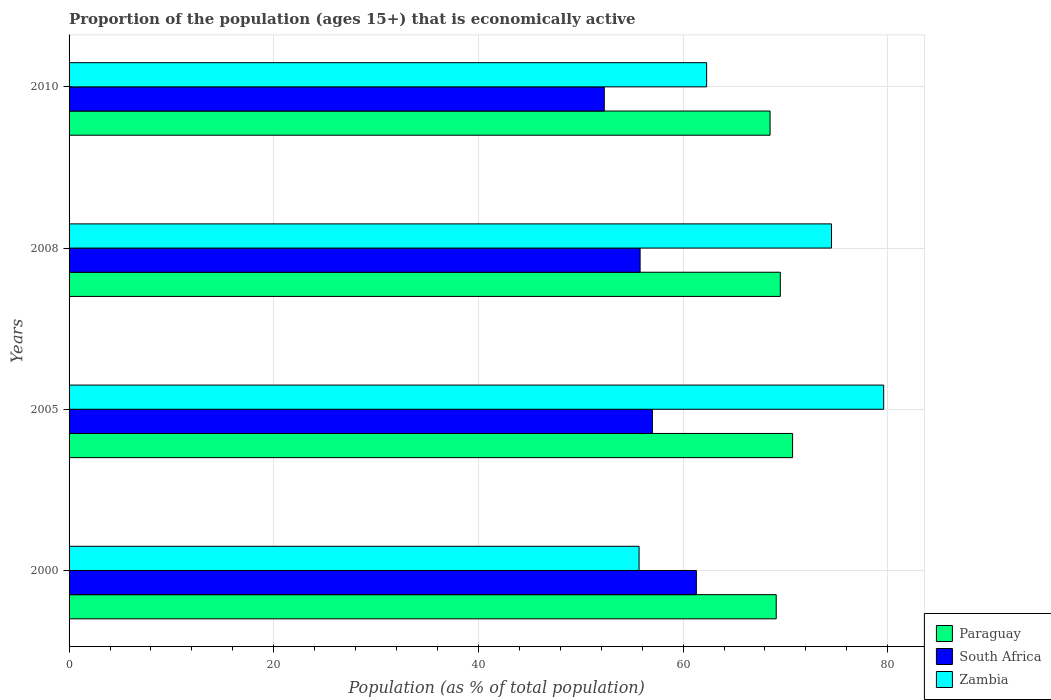How many different coloured bars are there?
Keep it short and to the point. 3. How many groups of bars are there?
Offer a very short reply. 4. Are the number of bars per tick equal to the number of legend labels?
Offer a terse response. Yes. How many bars are there on the 3rd tick from the top?
Keep it short and to the point. 3. What is the proportion of the population that is economically active in Zambia in 2005?
Give a very brief answer. 79.6. Across all years, what is the maximum proportion of the population that is economically active in Paraguay?
Provide a short and direct response. 70.7. Across all years, what is the minimum proportion of the population that is economically active in Zambia?
Offer a very short reply. 55.7. In which year was the proportion of the population that is economically active in Zambia maximum?
Make the answer very short. 2005. In which year was the proportion of the population that is economically active in South Africa minimum?
Make the answer very short. 2010. What is the total proportion of the population that is economically active in South Africa in the graph?
Provide a succinct answer. 226.4. What is the difference between the proportion of the population that is economically active in South Africa in 2005 and that in 2008?
Ensure brevity in your answer.  1.2. What is the average proportion of the population that is economically active in Zambia per year?
Ensure brevity in your answer.  68.02. What is the ratio of the proportion of the population that is economically active in Zambia in 2008 to that in 2010?
Your answer should be very brief. 1.2. Is the difference between the proportion of the population that is economically active in Paraguay in 2005 and 2008 greater than the difference between the proportion of the population that is economically active in Zambia in 2005 and 2008?
Your response must be concise. No. What is the difference between the highest and the second highest proportion of the population that is economically active in South Africa?
Offer a very short reply. 4.3. In how many years, is the proportion of the population that is economically active in South Africa greater than the average proportion of the population that is economically active in South Africa taken over all years?
Your response must be concise. 2. Is the sum of the proportion of the population that is economically active in Zambia in 2008 and 2010 greater than the maximum proportion of the population that is economically active in South Africa across all years?
Your response must be concise. Yes. What does the 2nd bar from the top in 2010 represents?
Offer a terse response. South Africa. What does the 2nd bar from the bottom in 2005 represents?
Offer a very short reply. South Africa. Are all the bars in the graph horizontal?
Keep it short and to the point. Yes. How many years are there in the graph?
Ensure brevity in your answer.  4. Are the values on the major ticks of X-axis written in scientific E-notation?
Your answer should be compact. No. Does the graph contain grids?
Your response must be concise. Yes. Where does the legend appear in the graph?
Ensure brevity in your answer.  Bottom right. How many legend labels are there?
Make the answer very short. 3. What is the title of the graph?
Provide a succinct answer. Proportion of the population (ages 15+) that is economically active. What is the label or title of the X-axis?
Offer a terse response. Population (as % of total population). What is the label or title of the Y-axis?
Offer a terse response. Years. What is the Population (as % of total population) in Paraguay in 2000?
Offer a terse response. 69.1. What is the Population (as % of total population) of South Africa in 2000?
Offer a very short reply. 61.3. What is the Population (as % of total population) in Zambia in 2000?
Give a very brief answer. 55.7. What is the Population (as % of total population) of Paraguay in 2005?
Your answer should be very brief. 70.7. What is the Population (as % of total population) in Zambia in 2005?
Offer a terse response. 79.6. What is the Population (as % of total population) of Paraguay in 2008?
Keep it short and to the point. 69.5. What is the Population (as % of total population) of South Africa in 2008?
Provide a succinct answer. 55.8. What is the Population (as % of total population) of Zambia in 2008?
Provide a succinct answer. 74.5. What is the Population (as % of total population) in Paraguay in 2010?
Provide a succinct answer. 68.5. What is the Population (as % of total population) in South Africa in 2010?
Your response must be concise. 52.3. What is the Population (as % of total population) in Zambia in 2010?
Ensure brevity in your answer.  62.3. Across all years, what is the maximum Population (as % of total population) of Paraguay?
Your response must be concise. 70.7. Across all years, what is the maximum Population (as % of total population) in South Africa?
Give a very brief answer. 61.3. Across all years, what is the maximum Population (as % of total population) in Zambia?
Provide a succinct answer. 79.6. Across all years, what is the minimum Population (as % of total population) in Paraguay?
Provide a succinct answer. 68.5. Across all years, what is the minimum Population (as % of total population) in South Africa?
Offer a terse response. 52.3. Across all years, what is the minimum Population (as % of total population) of Zambia?
Provide a succinct answer. 55.7. What is the total Population (as % of total population) in Paraguay in the graph?
Offer a terse response. 277.8. What is the total Population (as % of total population) in South Africa in the graph?
Provide a succinct answer. 226.4. What is the total Population (as % of total population) of Zambia in the graph?
Keep it short and to the point. 272.1. What is the difference between the Population (as % of total population) in Paraguay in 2000 and that in 2005?
Your answer should be very brief. -1.6. What is the difference between the Population (as % of total population) in Zambia in 2000 and that in 2005?
Provide a succinct answer. -23.9. What is the difference between the Population (as % of total population) in South Africa in 2000 and that in 2008?
Give a very brief answer. 5.5. What is the difference between the Population (as % of total population) in Zambia in 2000 and that in 2008?
Give a very brief answer. -18.8. What is the difference between the Population (as % of total population) of Paraguay in 2005 and that in 2008?
Provide a succinct answer. 1.2. What is the difference between the Population (as % of total population) in South Africa in 2005 and that in 2008?
Offer a terse response. 1.2. What is the difference between the Population (as % of total population) in Paraguay in 2005 and that in 2010?
Offer a very short reply. 2.2. What is the difference between the Population (as % of total population) of South Africa in 2005 and that in 2010?
Your answer should be compact. 4.7. What is the difference between the Population (as % of total population) of Zambia in 2005 and that in 2010?
Make the answer very short. 17.3. What is the difference between the Population (as % of total population) of Paraguay in 2000 and the Population (as % of total population) of South Africa in 2005?
Your answer should be very brief. 12.1. What is the difference between the Population (as % of total population) of South Africa in 2000 and the Population (as % of total population) of Zambia in 2005?
Ensure brevity in your answer.  -18.3. What is the difference between the Population (as % of total population) in South Africa in 2000 and the Population (as % of total population) in Zambia in 2008?
Provide a short and direct response. -13.2. What is the difference between the Population (as % of total population) in Paraguay in 2000 and the Population (as % of total population) in Zambia in 2010?
Offer a terse response. 6.8. What is the difference between the Population (as % of total population) of Paraguay in 2005 and the Population (as % of total population) of South Africa in 2008?
Your answer should be very brief. 14.9. What is the difference between the Population (as % of total population) of South Africa in 2005 and the Population (as % of total population) of Zambia in 2008?
Your response must be concise. -17.5. What is the difference between the Population (as % of total population) in South Africa in 2005 and the Population (as % of total population) in Zambia in 2010?
Ensure brevity in your answer.  -5.3. What is the difference between the Population (as % of total population) in Paraguay in 2008 and the Population (as % of total population) in South Africa in 2010?
Your answer should be very brief. 17.2. What is the difference between the Population (as % of total population) of Paraguay in 2008 and the Population (as % of total population) of Zambia in 2010?
Offer a terse response. 7.2. What is the difference between the Population (as % of total population) of South Africa in 2008 and the Population (as % of total population) of Zambia in 2010?
Your answer should be compact. -6.5. What is the average Population (as % of total population) of Paraguay per year?
Provide a short and direct response. 69.45. What is the average Population (as % of total population) of South Africa per year?
Give a very brief answer. 56.6. What is the average Population (as % of total population) in Zambia per year?
Your answer should be very brief. 68.03. In the year 2000, what is the difference between the Population (as % of total population) in Paraguay and Population (as % of total population) in South Africa?
Make the answer very short. 7.8. In the year 2000, what is the difference between the Population (as % of total population) in South Africa and Population (as % of total population) in Zambia?
Provide a succinct answer. 5.6. In the year 2005, what is the difference between the Population (as % of total population) in South Africa and Population (as % of total population) in Zambia?
Your response must be concise. -22.6. In the year 2008, what is the difference between the Population (as % of total population) in South Africa and Population (as % of total population) in Zambia?
Offer a very short reply. -18.7. What is the ratio of the Population (as % of total population) of Paraguay in 2000 to that in 2005?
Keep it short and to the point. 0.98. What is the ratio of the Population (as % of total population) of South Africa in 2000 to that in 2005?
Your response must be concise. 1.08. What is the ratio of the Population (as % of total population) of Zambia in 2000 to that in 2005?
Make the answer very short. 0.7. What is the ratio of the Population (as % of total population) of Paraguay in 2000 to that in 2008?
Offer a very short reply. 0.99. What is the ratio of the Population (as % of total population) of South Africa in 2000 to that in 2008?
Give a very brief answer. 1.1. What is the ratio of the Population (as % of total population) in Zambia in 2000 to that in 2008?
Make the answer very short. 0.75. What is the ratio of the Population (as % of total population) of Paraguay in 2000 to that in 2010?
Offer a terse response. 1.01. What is the ratio of the Population (as % of total population) of South Africa in 2000 to that in 2010?
Your response must be concise. 1.17. What is the ratio of the Population (as % of total population) in Zambia in 2000 to that in 2010?
Provide a succinct answer. 0.89. What is the ratio of the Population (as % of total population) in Paraguay in 2005 to that in 2008?
Ensure brevity in your answer.  1.02. What is the ratio of the Population (as % of total population) in South Africa in 2005 to that in 2008?
Provide a short and direct response. 1.02. What is the ratio of the Population (as % of total population) in Zambia in 2005 to that in 2008?
Make the answer very short. 1.07. What is the ratio of the Population (as % of total population) of Paraguay in 2005 to that in 2010?
Your response must be concise. 1.03. What is the ratio of the Population (as % of total population) of South Africa in 2005 to that in 2010?
Ensure brevity in your answer.  1.09. What is the ratio of the Population (as % of total population) in Zambia in 2005 to that in 2010?
Your response must be concise. 1.28. What is the ratio of the Population (as % of total population) of Paraguay in 2008 to that in 2010?
Offer a terse response. 1.01. What is the ratio of the Population (as % of total population) of South Africa in 2008 to that in 2010?
Ensure brevity in your answer.  1.07. What is the ratio of the Population (as % of total population) in Zambia in 2008 to that in 2010?
Make the answer very short. 1.2. What is the difference between the highest and the lowest Population (as % of total population) of Paraguay?
Keep it short and to the point. 2.2. What is the difference between the highest and the lowest Population (as % of total population) in Zambia?
Offer a very short reply. 23.9. 